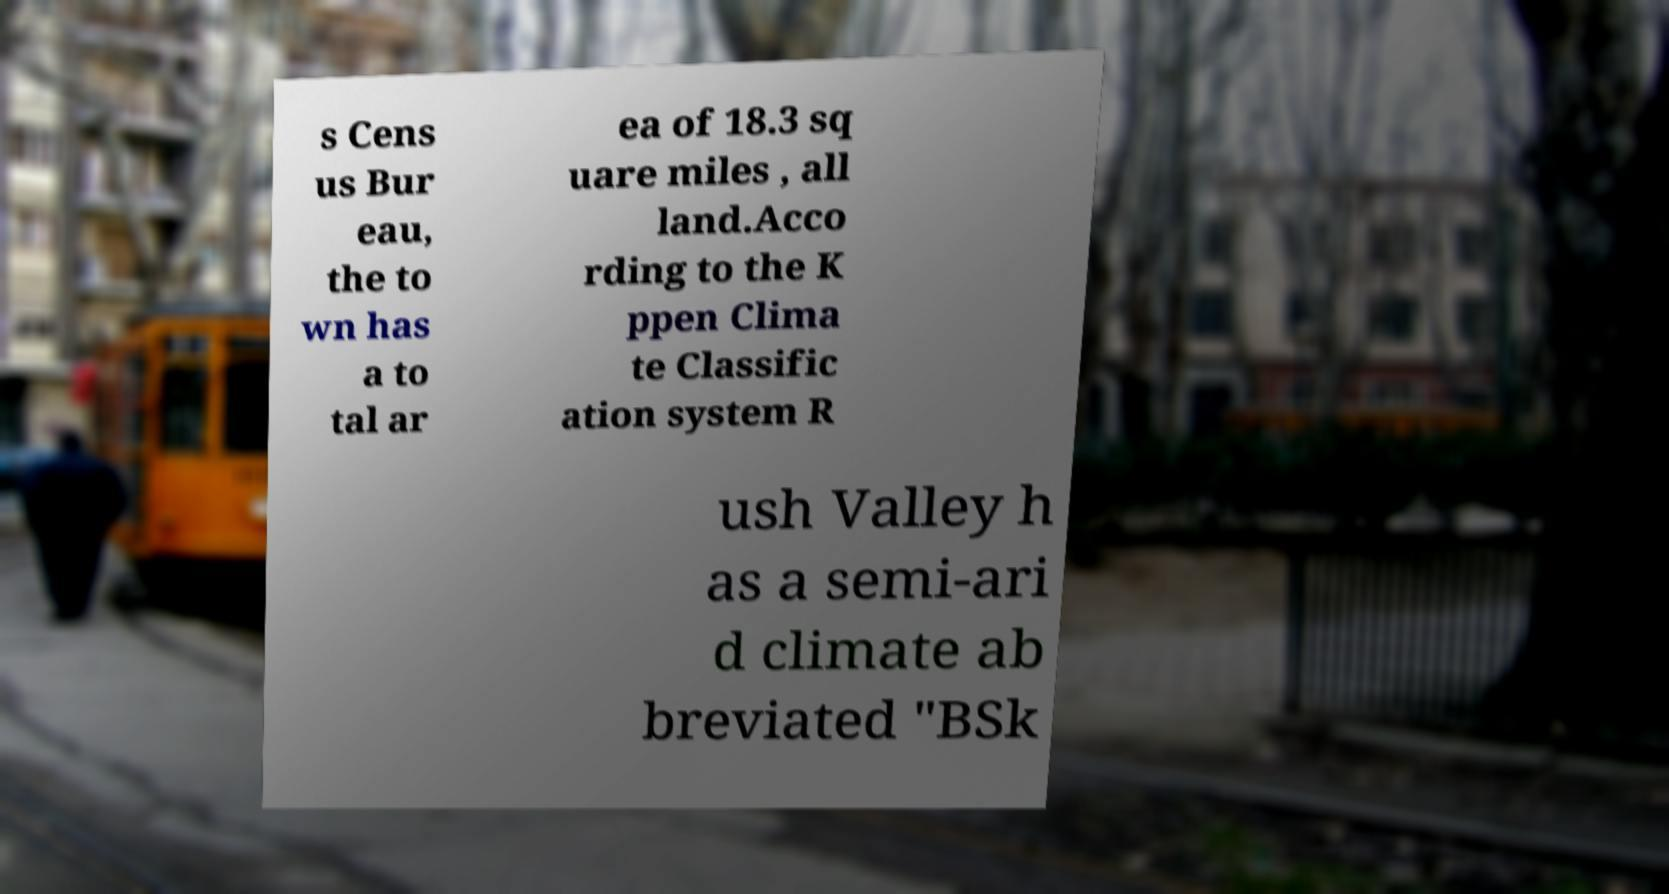What messages or text are displayed in this image? I need them in a readable, typed format. s Cens us Bur eau, the to wn has a to tal ar ea of 18.3 sq uare miles , all land.Acco rding to the K ppen Clima te Classific ation system R ush Valley h as a semi-ari d climate ab breviated "BSk 